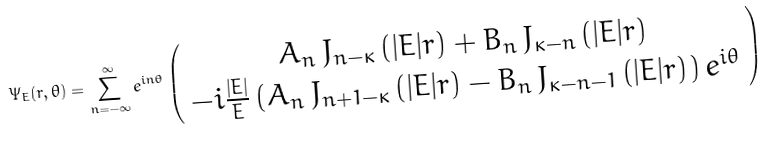<formula> <loc_0><loc_0><loc_500><loc_500>\Psi _ { E } ( r , \theta ) = \sum _ { n = - \infty } ^ { \infty } e ^ { i n \theta } \left ( \begin{array} { c } { { A _ { n } \, J _ { n - \kappa } \left ( | E | r \right ) + B _ { n } \, J _ { \kappa - n } \left ( | E | r \right ) } } \\ { { - i \frac { | E | } { E } \left ( A _ { n } \, J _ { n + 1 - \kappa } \left ( | E | r \right ) - B _ { n } \, J _ { \kappa - n - 1 } \left ( | E | r \right ) \right ) e ^ { i \theta } } } \end{array} \right )</formula> 